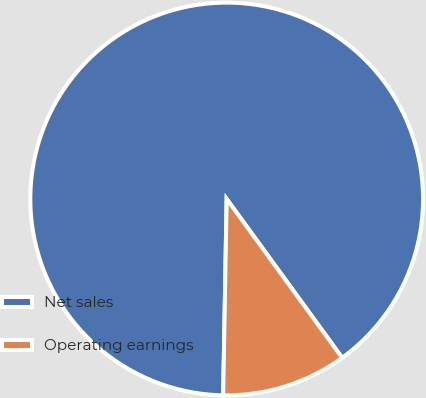Convert chart to OTSL. <chart><loc_0><loc_0><loc_500><loc_500><pie_chart><fcel>Net sales<fcel>Operating earnings<nl><fcel>89.71%<fcel>10.29%<nl></chart> 